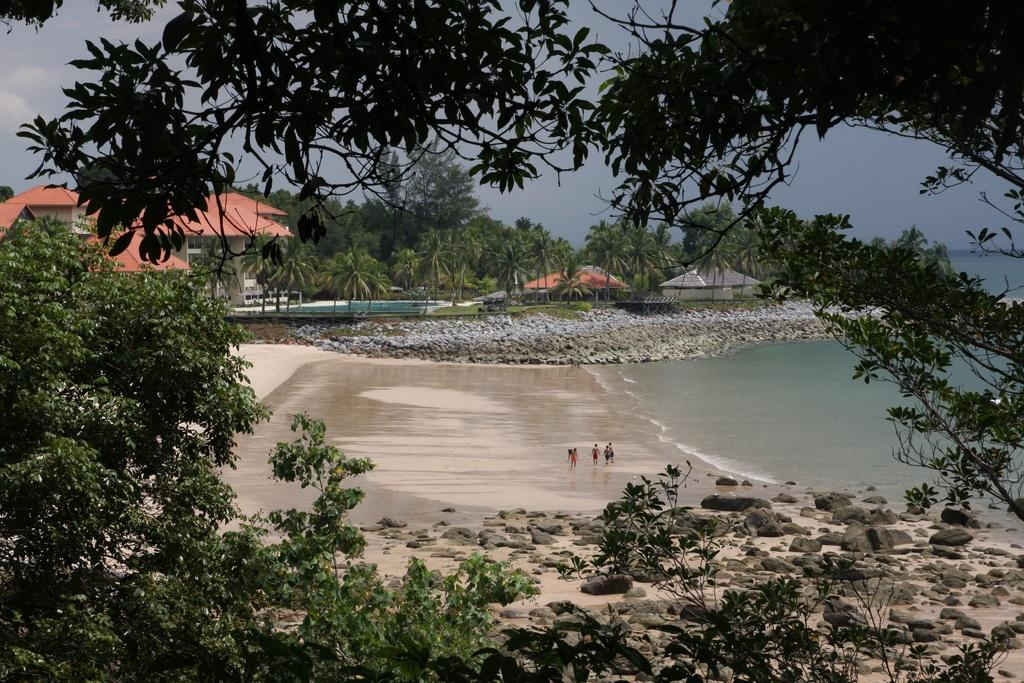What are the people in the image doing? The people in the image are in the water. What other elements can be seen in the image besides the people? There are plants, trees, houses, stones, and the sky visible in the image. Can you describe the natural elements in the image? There are plants and trees present in the image. What type of structures can be seen in the image? There are houses visible in the image. What is visible in the background of the image? The sky is visible in the background of the image. What color is the wren's stocking in the image? There is no wren or stocking present in the image. Who is the owner of the house in the image? The image does not provide information about the ownership of the houses. 